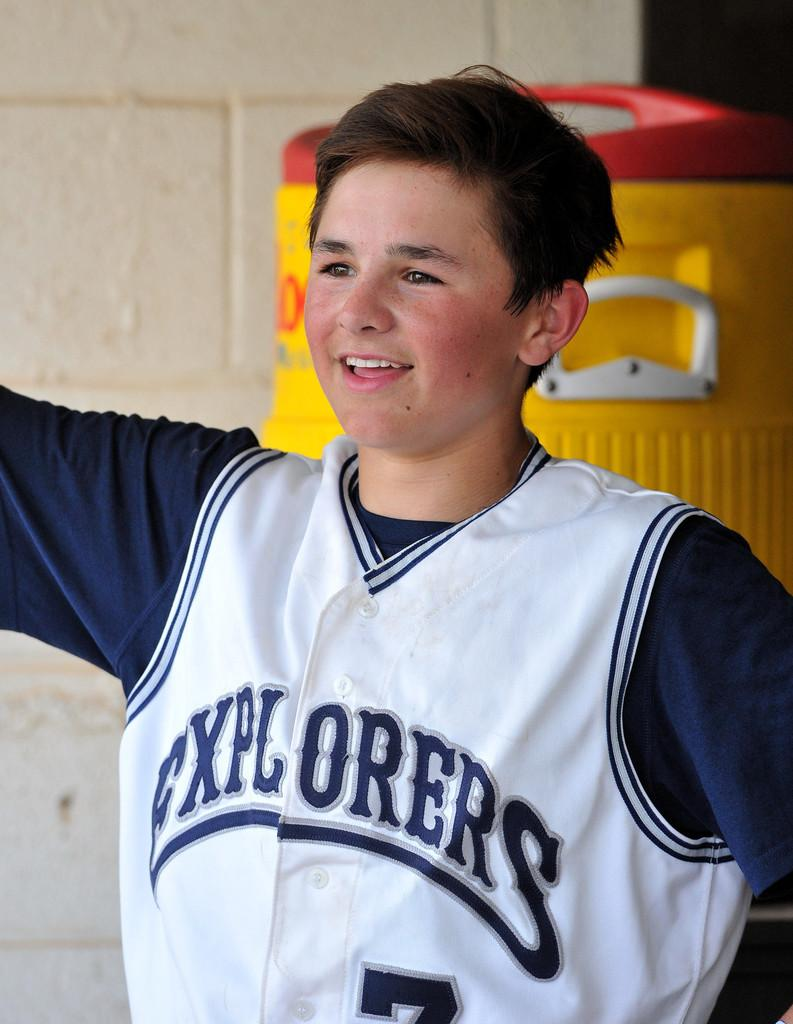<image>
Render a clear and concise summary of the photo. A boy wearing an Explorers jersey with the number 7. 